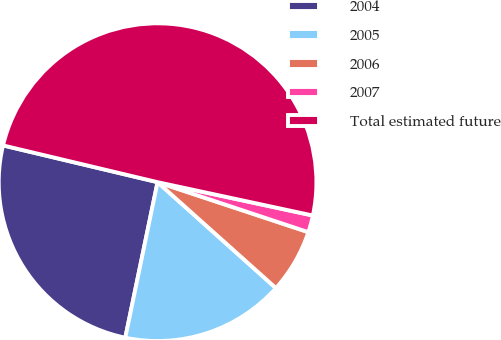<chart> <loc_0><loc_0><loc_500><loc_500><pie_chart><fcel>2004<fcel>2005<fcel>2006<fcel>2007<fcel>Total estimated future<nl><fcel>25.46%<fcel>16.64%<fcel>6.52%<fcel>1.73%<fcel>49.65%<nl></chart> 